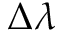Convert formula to latex. <formula><loc_0><loc_0><loc_500><loc_500>\Delta \lambda</formula> 